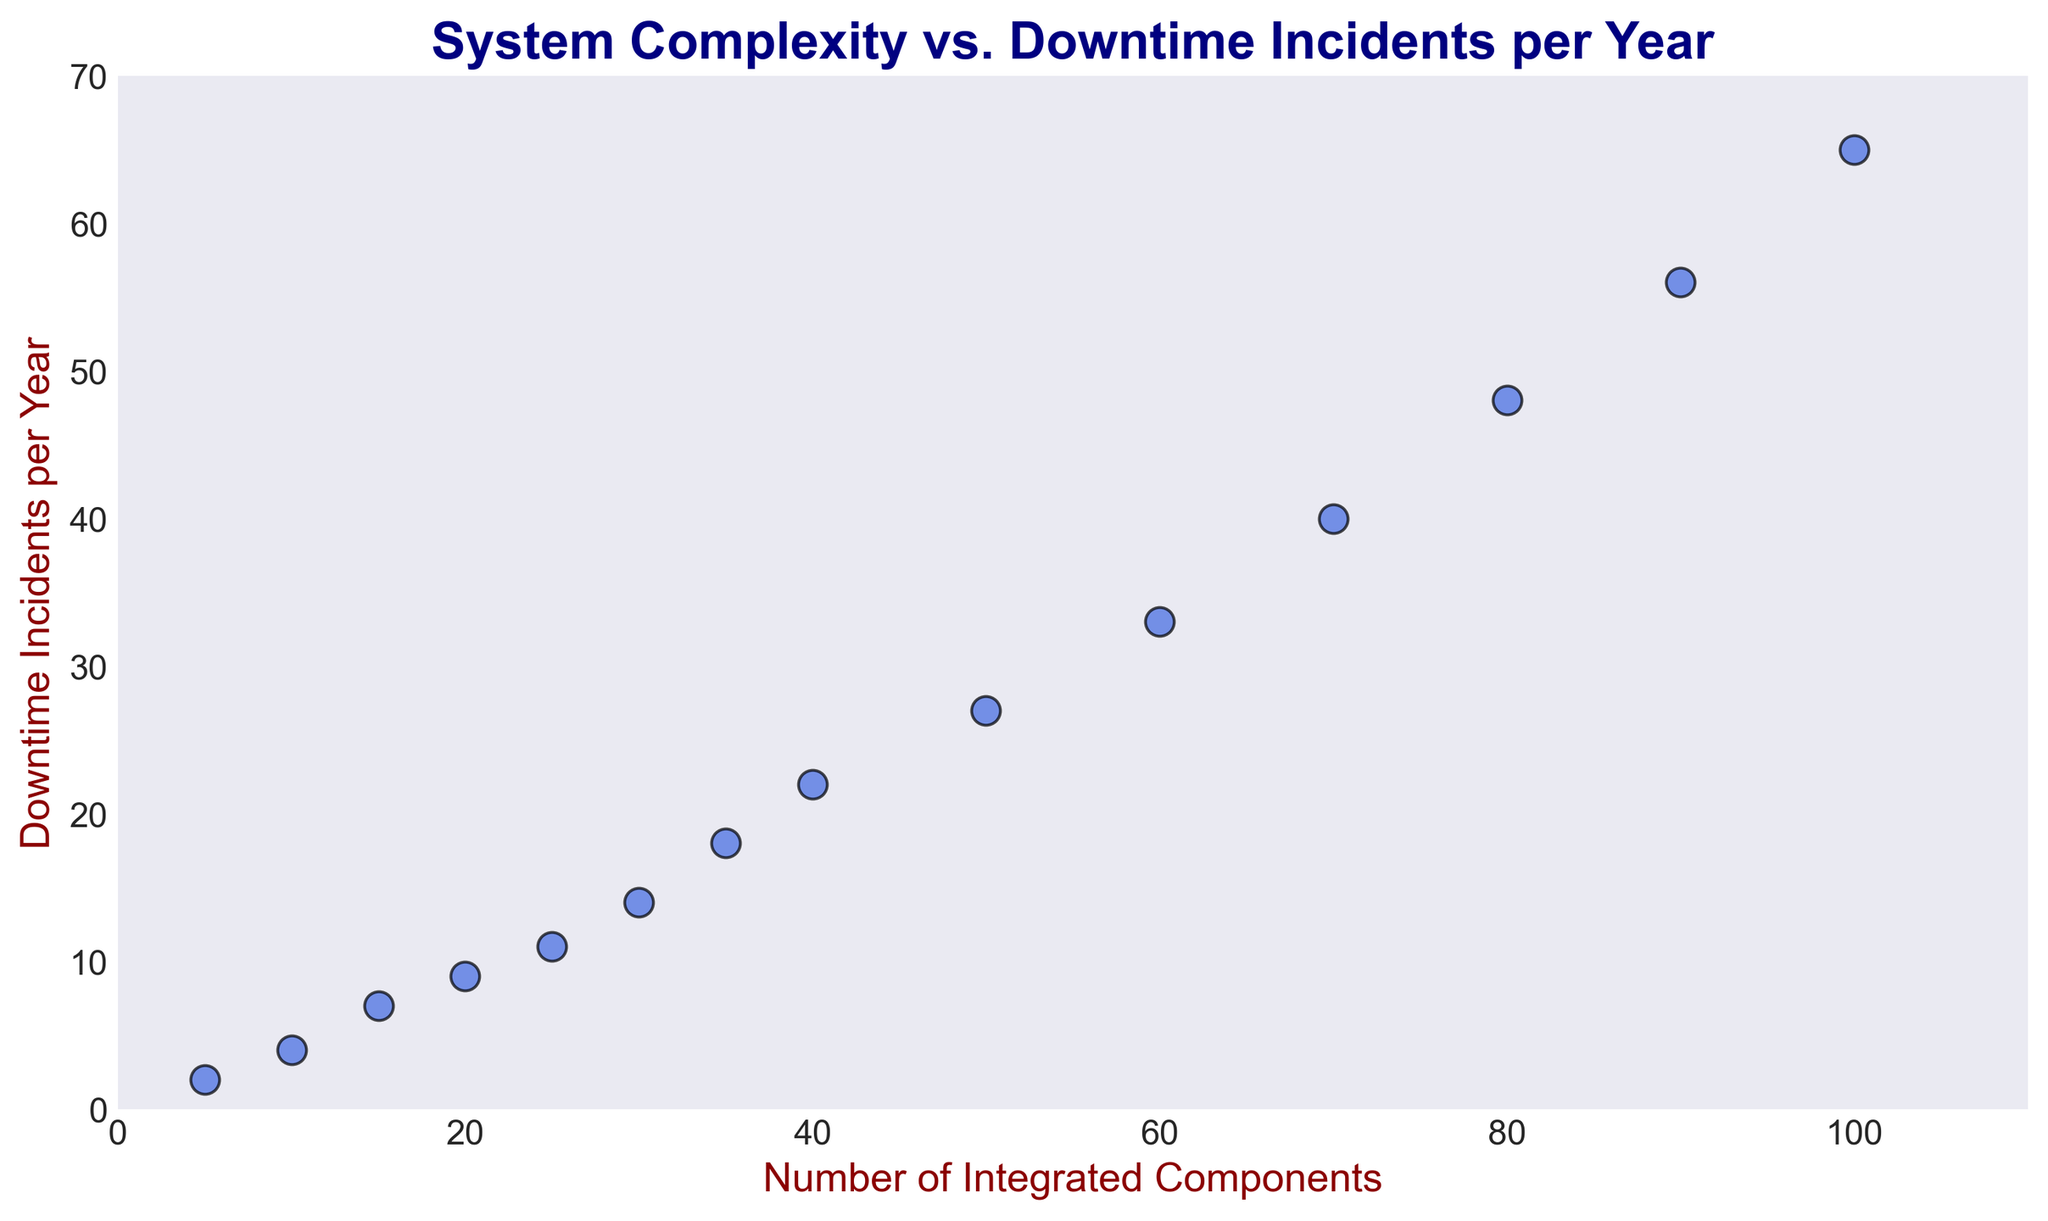What is the relationship between the number of integrated components and downtime incidents per year? The scatter plot shows that as the number of integrated components increases, the number of downtime incidents per year also increases. This indicates a positive correlation between system complexity (measured by the number of integrated components) and downtime incidents.
Answer: Positive correlation How many downtime incidents per year are observed when there are 60 integrated components? From the scatter plot, when there are 60 integrated components, the number of downtime incidents per year is shown as a point on the graph. Locate the point corresponding to 60 on the x-axis and read the value on the y-axis.
Answer: 33 Which system with a specific number of integrated components exhibits the highest number of downtime incidents per year? Identify the point with the highest y-value on the scatter plot. This point corresponds to the system with the highest number of downtime incidents.
Answer: 100 components What is the difference in the number of downtime incidents per year between systems with 10 and 80 integrated components? Locate the points corresponding to 10 and 80 components on the x-axis and read their respective y-values. Subtract the number of downtime incidents at 10 components from the number of downtime incidents at 80 components: 48 - 4 = 44.
Answer: 44 What is the average number of downtime incidents per year for systems with 30, 40, and 50 integrated components? Find the y-values corresponding to 30, 40, and 50 components. The values are 14, 22, and 27 respectively. Calculate the average: (14 + 22 + 27) / 3 = 63 / 3 = 21.
Answer: 21 How does the number of downtime incidents per year change from 25 to 35 integrated components? Locate the points for 25 and 35 components on the x-axis and their y-values, which are 11 and 18 respectively. Calculate the difference: 18 - 11 = 7.
Answer: 7 Does a system with 50 components have more or fewer downtime incidents per year than a system with 35 components? Compare the y-values for 50 and 35 components. The value for 50 components is 27 and for 35 components is 18. Since 27 > 18, the system with 50 components has more downtime incidents per year.
Answer: More Is there a significant increase in downtime incidents beyond 70 integrated components? Observe the trend in the scatter plot as the number of components increases beyond 70. The points show a continuous upward trend, indicating a significant increase in downtime incidents as the number of components exceeds 70.
Answer: Yes At what number of integrated components does the system reach 40 downtime incidents per year? Find the point on the scatter plot where the y-value is 40 and read its corresponding x-value. This occurs at 70 integrated components.
Answer: 70 components 